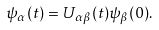Convert formula to latex. <formula><loc_0><loc_0><loc_500><loc_500>\psi _ { \alpha } ( t ) = U _ { \alpha \beta } ( t ) \psi _ { \beta } ( 0 ) .</formula> 